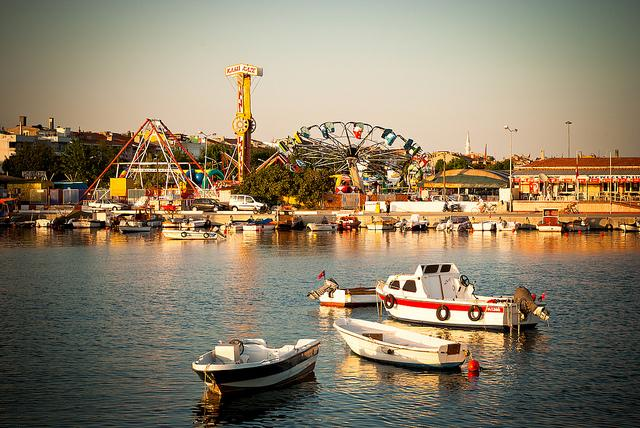Where can you see a similar scene to what is happening behind the boats? amusement park 